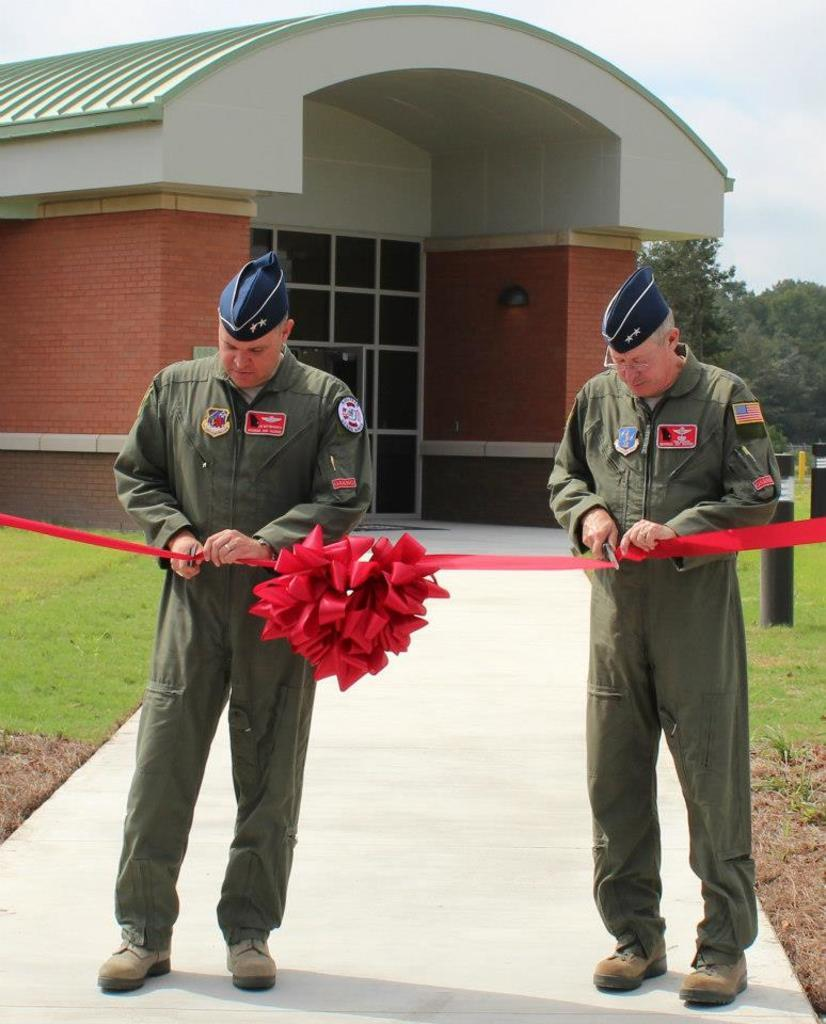How many people are in the image? There are two persons in the image. What are the two persons doing in the image? The two persons are cutting a ribbon. What type of vegetation is present in the image? There is grass in the image. What can be seen in the background of the image? There is a building, trees, and the sky visible in the background of the image. Can you see a tiger or an owl in the image? No, there are no tigers or owls present in the image. What type of jelly is being used to cut the ribbon in the image? There is no jelly involved in cutting the ribbon in the image. 